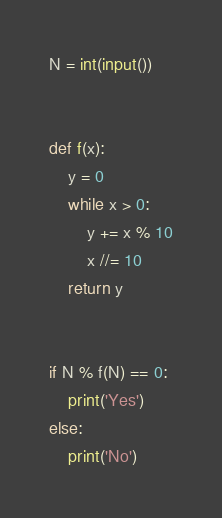<code> <loc_0><loc_0><loc_500><loc_500><_Python_>N = int(input())


def f(x):
    y = 0
    while x > 0:
        y += x % 10
        x //= 10
    return y


if N % f(N) == 0:
    print('Yes')
else:
    print('No')
</code> 